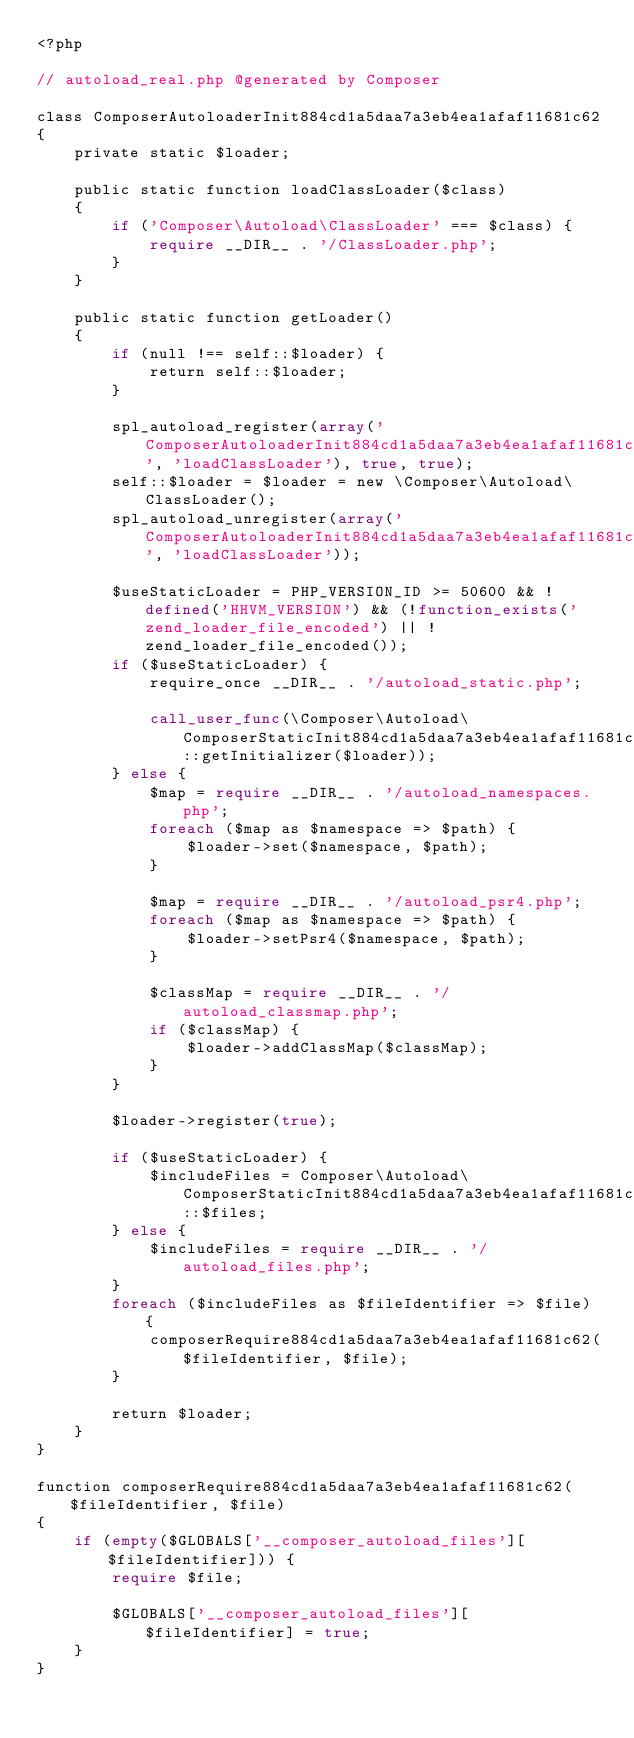<code> <loc_0><loc_0><loc_500><loc_500><_PHP_><?php

// autoload_real.php @generated by Composer

class ComposerAutoloaderInit884cd1a5daa7a3eb4ea1afaf11681c62
{
    private static $loader;

    public static function loadClassLoader($class)
    {
        if ('Composer\Autoload\ClassLoader' === $class) {
            require __DIR__ . '/ClassLoader.php';
        }
    }

    public static function getLoader()
    {
        if (null !== self::$loader) {
            return self::$loader;
        }

        spl_autoload_register(array('ComposerAutoloaderInit884cd1a5daa7a3eb4ea1afaf11681c62', 'loadClassLoader'), true, true);
        self::$loader = $loader = new \Composer\Autoload\ClassLoader();
        spl_autoload_unregister(array('ComposerAutoloaderInit884cd1a5daa7a3eb4ea1afaf11681c62', 'loadClassLoader'));

        $useStaticLoader = PHP_VERSION_ID >= 50600 && !defined('HHVM_VERSION') && (!function_exists('zend_loader_file_encoded') || !zend_loader_file_encoded());
        if ($useStaticLoader) {
            require_once __DIR__ . '/autoload_static.php';

            call_user_func(\Composer\Autoload\ComposerStaticInit884cd1a5daa7a3eb4ea1afaf11681c62::getInitializer($loader));
        } else {
            $map = require __DIR__ . '/autoload_namespaces.php';
            foreach ($map as $namespace => $path) {
                $loader->set($namespace, $path);
            }

            $map = require __DIR__ . '/autoload_psr4.php';
            foreach ($map as $namespace => $path) {
                $loader->setPsr4($namespace, $path);
            }

            $classMap = require __DIR__ . '/autoload_classmap.php';
            if ($classMap) {
                $loader->addClassMap($classMap);
            }
        }

        $loader->register(true);

        if ($useStaticLoader) {
            $includeFiles = Composer\Autoload\ComposerStaticInit884cd1a5daa7a3eb4ea1afaf11681c62::$files;
        } else {
            $includeFiles = require __DIR__ . '/autoload_files.php';
        }
        foreach ($includeFiles as $fileIdentifier => $file) {
            composerRequire884cd1a5daa7a3eb4ea1afaf11681c62($fileIdentifier, $file);
        }

        return $loader;
    }
}

function composerRequire884cd1a5daa7a3eb4ea1afaf11681c62($fileIdentifier, $file)
{
    if (empty($GLOBALS['__composer_autoload_files'][$fileIdentifier])) {
        require $file;

        $GLOBALS['__composer_autoload_files'][$fileIdentifier] = true;
    }
}
</code> 